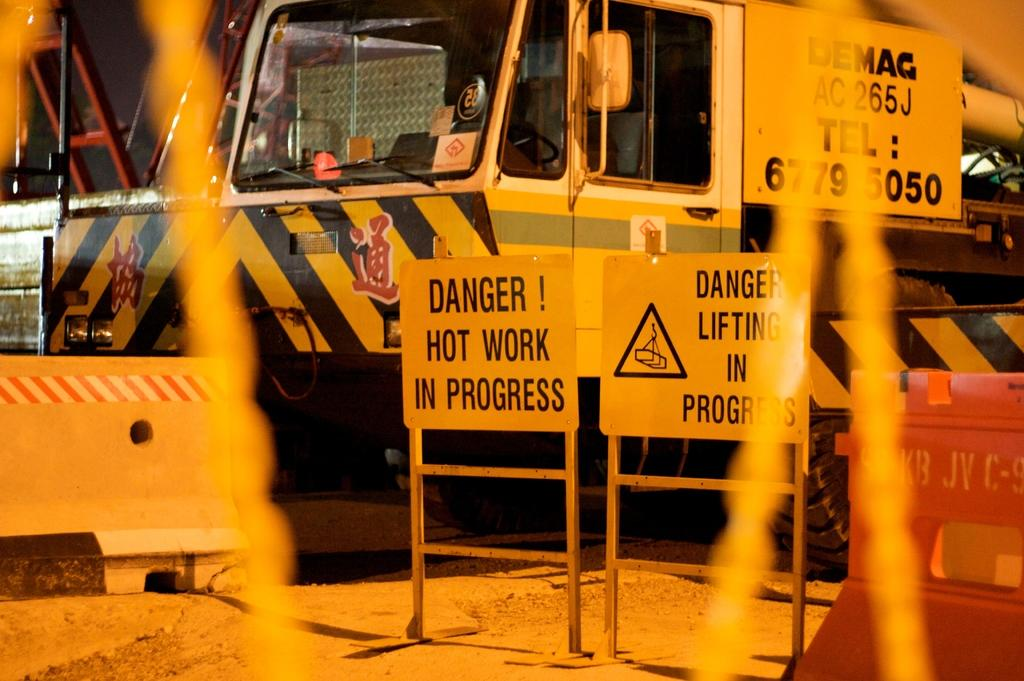<image>
Give a short and clear explanation of the subsequent image. A bright yellow truck parked behind standing danger signs. 